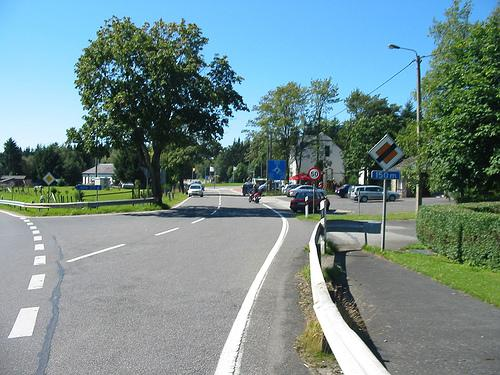Question: what is in the photo?
Choices:
A. Cars.
B. Trains.
C. Airplanes.
D. Tractors.
Answer with the letter. Answer: A Question: what else is in the photo?
Choices:
A. Berry bushes.
B. Flowers.
C. Butterflies.
D. Trees.
Answer with the letter. Answer: D Question: why are there shadows?
Choices:
A. Night time.
B. Tall buildings.
C. Many trees.
D. Light.
Answer with the letter. Answer: D 